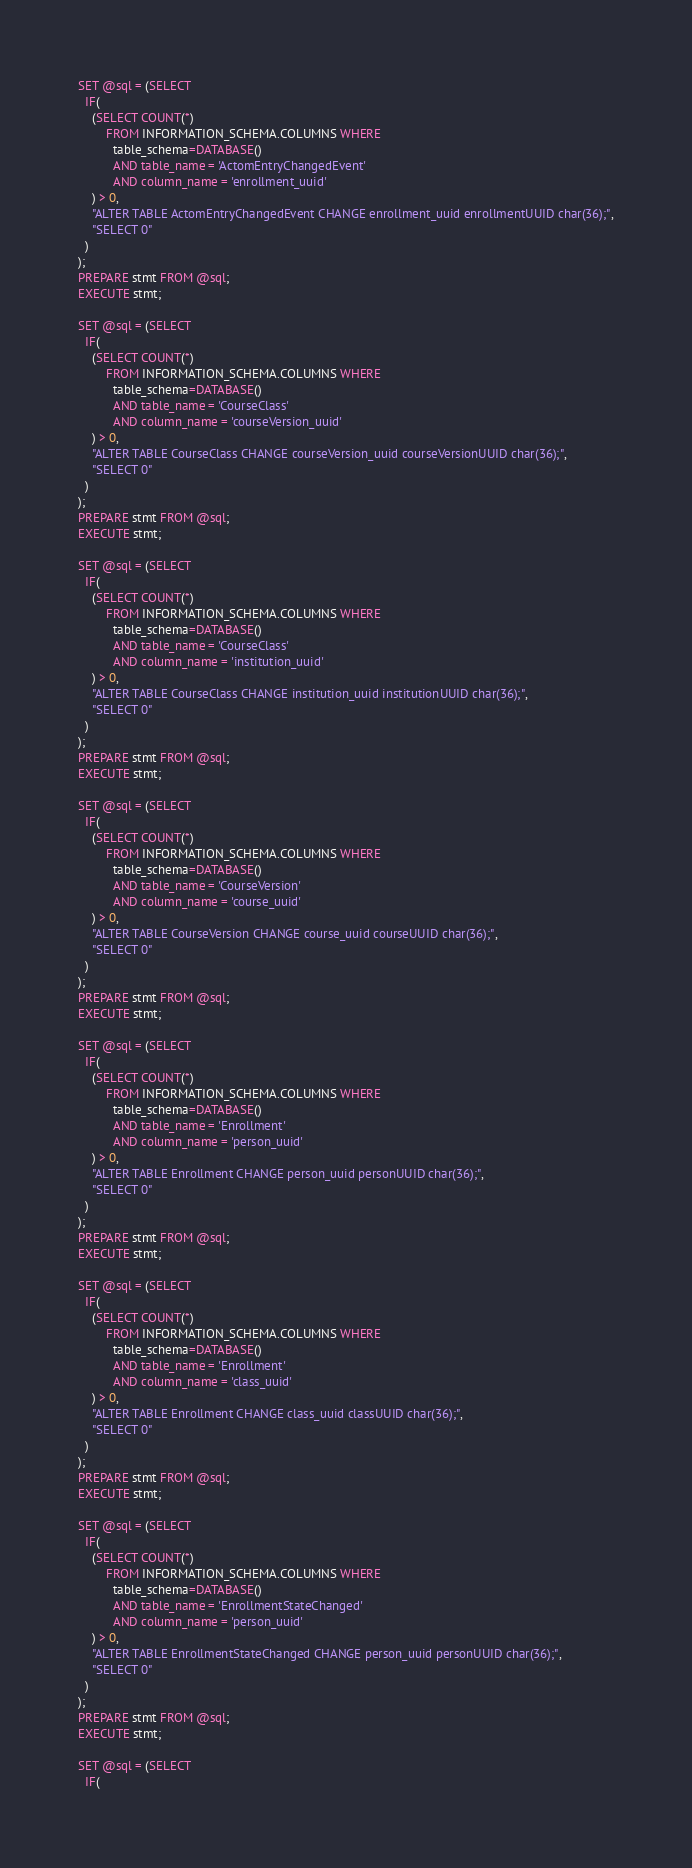Convert code to text. <code><loc_0><loc_0><loc_500><loc_500><_SQL_>
SET @sql = (SELECT 
  IF(
    (SELECT COUNT(*)
        FROM INFORMATION_SCHEMA.COLUMNS WHERE
          table_schema=DATABASE() 
          AND table_name = 'ActomEntryChangedEvent'
          AND column_name = 'enrollment_uuid'
    ) > 0,
    "ALTER TABLE ActomEntryChangedEvent CHANGE enrollment_uuid enrollmentUUID char(36);",
    "SELECT 0"
  )
);
PREPARE stmt FROM @sql;
EXECUTE stmt;

SET @sql = (SELECT 
  IF(
    (SELECT COUNT(*)
        FROM INFORMATION_SCHEMA.COLUMNS WHERE
          table_schema=DATABASE() 
          AND table_name = 'CourseClass'
          AND column_name = 'courseVersion_uuid'
    ) > 0,
    "ALTER TABLE CourseClass CHANGE courseVersion_uuid courseVersionUUID char(36);",
    "SELECT 0"
  )
);
PREPARE stmt FROM @sql;
EXECUTE stmt;

SET @sql = (SELECT 
  IF(
    (SELECT COUNT(*)
        FROM INFORMATION_SCHEMA.COLUMNS WHERE
          table_schema=DATABASE() 
          AND table_name = 'CourseClass'
          AND column_name = 'institution_uuid'
    ) > 0,
    "ALTER TABLE CourseClass CHANGE institution_uuid institutionUUID char(36);",
    "SELECT 0"
  )
);
PREPARE stmt FROM @sql;
EXECUTE stmt;

SET @sql = (SELECT 
  IF(
    (SELECT COUNT(*)
        FROM INFORMATION_SCHEMA.COLUMNS WHERE
          table_schema=DATABASE() 
          AND table_name = 'CourseVersion'
          AND column_name = 'course_uuid'
    ) > 0,
    "ALTER TABLE CourseVersion CHANGE course_uuid courseUUID char(36);",
    "SELECT 0"
  )
);
PREPARE stmt FROM @sql;
EXECUTE stmt;

SET @sql = (SELECT 
  IF(
    (SELECT COUNT(*)
        FROM INFORMATION_SCHEMA.COLUMNS WHERE
          table_schema=DATABASE() 
          AND table_name = 'Enrollment'
          AND column_name = 'person_uuid'
    ) > 0,
    "ALTER TABLE Enrollment CHANGE person_uuid personUUID char(36);",
    "SELECT 0"
  )
);
PREPARE stmt FROM @sql;
EXECUTE stmt;

SET @sql = (SELECT 
  IF(
    (SELECT COUNT(*)
        FROM INFORMATION_SCHEMA.COLUMNS WHERE
          table_schema=DATABASE() 
          AND table_name = 'Enrollment'
          AND column_name = 'class_uuid'
    ) > 0,
    "ALTER TABLE Enrollment CHANGE class_uuid classUUID char(36);",
    "SELECT 0"
  )
);
PREPARE stmt FROM @sql;
EXECUTE stmt;

SET @sql = (SELECT 
  IF(
    (SELECT COUNT(*)
        FROM INFORMATION_SCHEMA.COLUMNS WHERE
          table_schema=DATABASE() 
          AND table_name = 'EnrollmentStateChanged'
          AND column_name = 'person_uuid'
    ) > 0,
    "ALTER TABLE EnrollmentStateChanged CHANGE person_uuid personUUID char(36);",
    "SELECT 0"
  )
);
PREPARE stmt FROM @sql;
EXECUTE stmt;

SET @sql = (SELECT 
  IF(</code> 